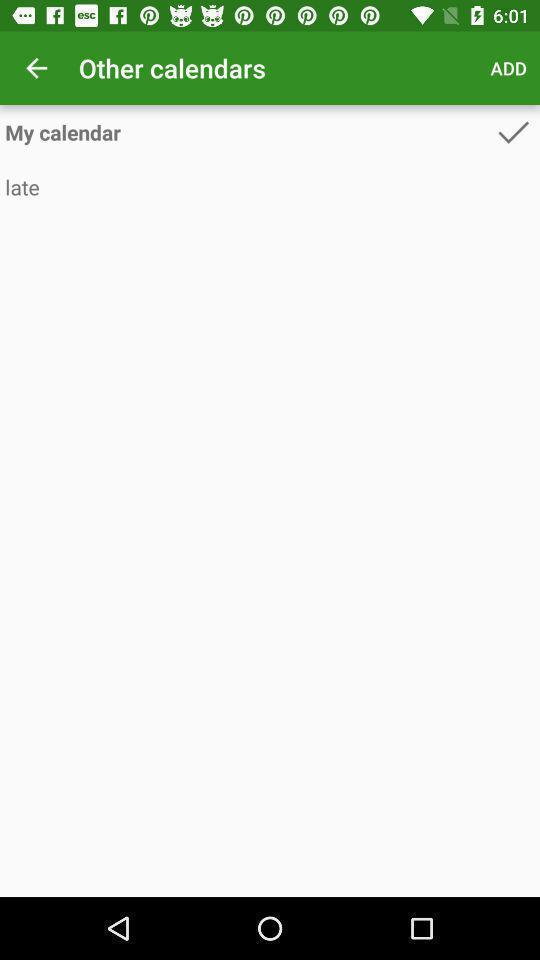Provide a description of this screenshot. Page with calendar details in period tracker. 